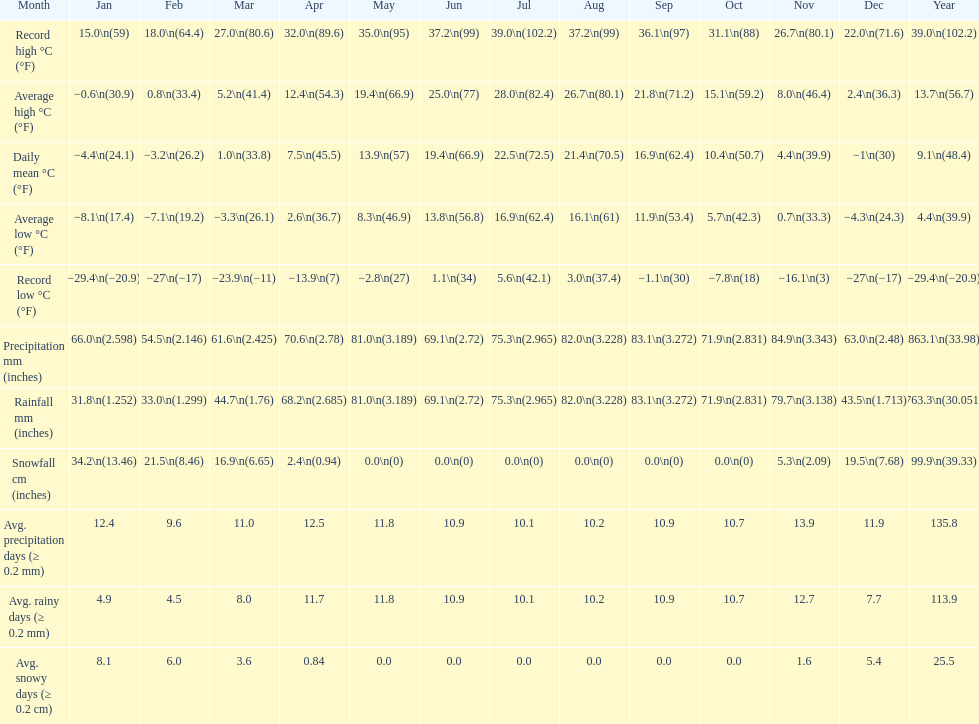During which month was the mean high temperature 2 September. 